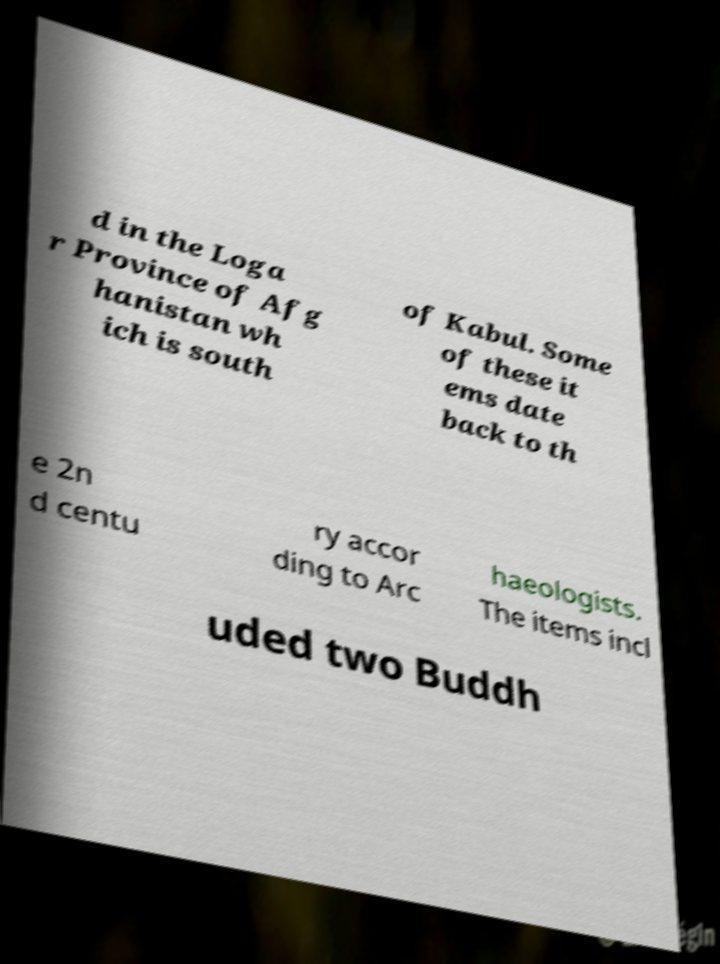I need the written content from this picture converted into text. Can you do that? d in the Loga r Province of Afg hanistan wh ich is south of Kabul. Some of these it ems date back to th e 2n d centu ry accor ding to Arc haeologists. The items incl uded two Buddh 